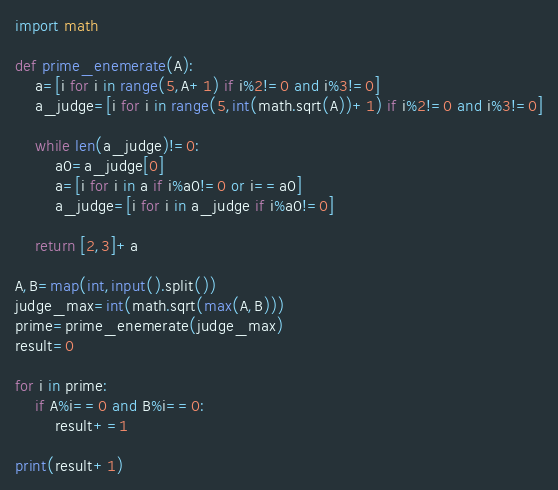Convert code to text. <code><loc_0><loc_0><loc_500><loc_500><_Python_>import math

def prime_enemerate(A):
    a=[i for i in range(5,A+1) if i%2!=0 and i%3!=0]
    a_judge=[i for i in range(5,int(math.sqrt(A))+1) if i%2!=0 and i%3!=0]

    while len(a_judge)!=0:
        a0=a_judge[0]
        a=[i for i in a if i%a0!=0 or i==a0]
        a_judge=[i for i in a_judge if i%a0!=0]

    return [2,3]+a

A,B=map(int,input().split())
judge_max=int(math.sqrt(max(A,B)))
prime=prime_enemerate(judge_max)
result=0

for i in prime:
    if A%i==0 and B%i==0:
        result+=1

print(result+1)</code> 